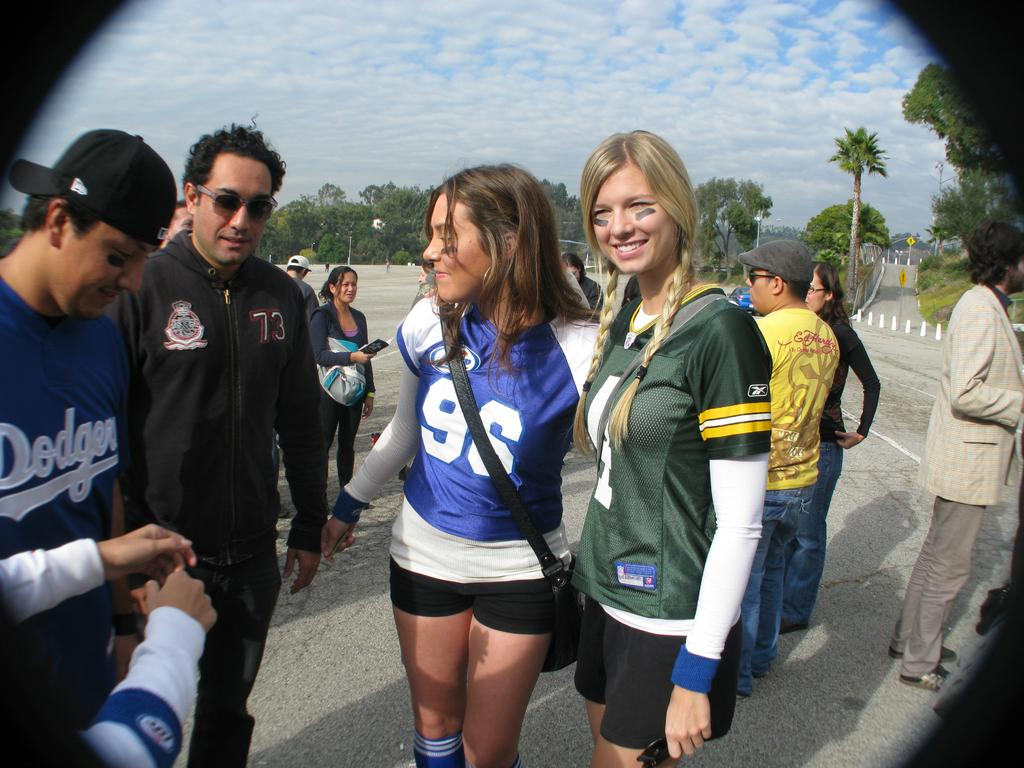Provide a one-sentence caption for the provided image. A girl has the number 96 on her jersey and is talking to others. 